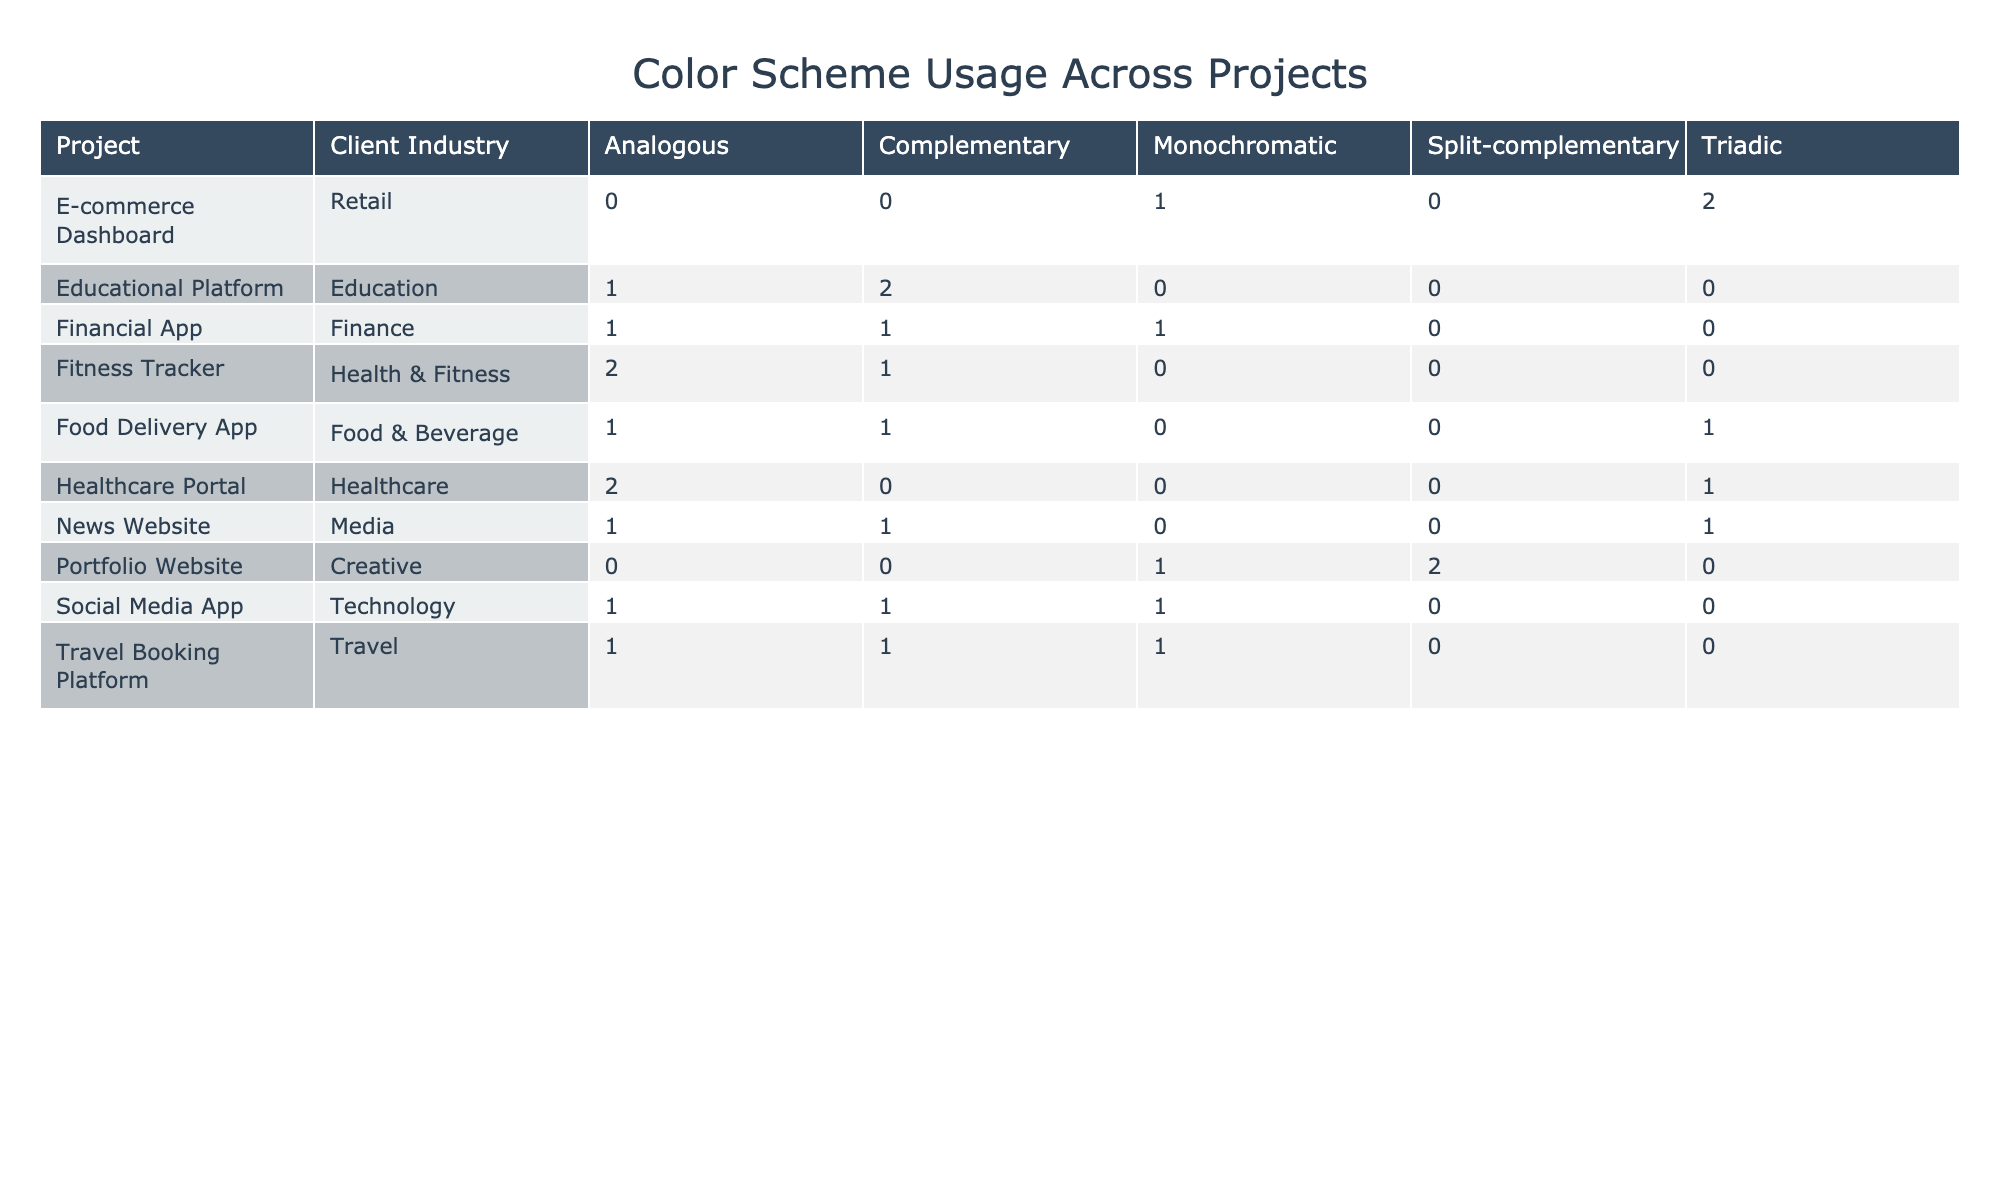What is the total number of projects using a Triadic color scheme? To find the total number of projects using a Triadic color scheme, I will look across the table to count the number of entries in the Triadic column. There are 5 projects listed under the Triadic color scheme.
Answer: 5 Which client industry has the most projects listed? By examining the number of entries under each client industry, I can see that the Technology industry has the most projects listed, with a total of 3 projects: Social Media App and two projects for Healthcare Portal.
Answer: Technology Is there any project in the Finance industry that uses a Split-complementary color scheme? I will check the Finance industry row to determine if there are any entries listed under the Split-complementary column. Upon reviewing the table, there are no projects in the Finance industry that utilize a Split-complementary color scheme.
Answer: No How many projects use Monochromatic colors and are in the Creative industry? I will review the Monochromatic column specifically for projects within the Creative industry. There are 3 projects that fit this criterion: the Background, Gallery, and the Footer of the Portfolio Website.
Answer: 3 What is the total count of UI elements across all projects in the Food & Beverage industry? I will count the number of UI elements listed in the Food & Beverage industry row. The unique entries under this industry are Restaurant Listing, Order Status, and User Profile. Thus, the total count of UI elements is 3.
Answer: 3 Are there more Analogous color schemes in the Health & Fitness industry than in the Technology industry? To answer this, I will examine the count of Analogous color schemes in both the Health & Fitness and Technology industries. The Health & Fitness industry has 3 entries, while the Technology industry has only 2. Therefore, there are more Analogous color schemes in Health & Fitness.
Answer: Yes Which project in the Media industry has the highest count of UI elements? I will view the Media industry entry to see the associated project and count the number of UI elements. The News Website has 3 UI elements: Article Card, Category Tags, and Advertisement, which is the highest count.
Answer: News Website What proportion of projects in the Travel industry use a Complementary color scheme? I will first count the total projects in the Travel industry, which is 3 (Search Bar, Calendar, Promotion Banner), and the number utilizing Complementary, which is 1 (Search Bar). The proportion is calculated as 1 (Complementary) divided by 3 (total), which is approximately 0.33.
Answer: 0.33 